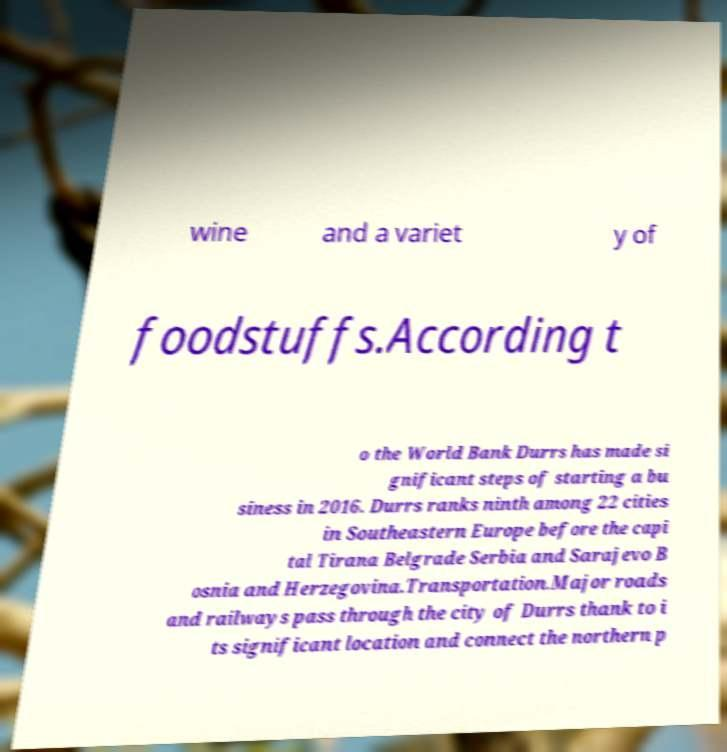Could you assist in decoding the text presented in this image and type it out clearly? wine and a variet y of foodstuffs.According t o the World Bank Durrs has made si gnificant steps of starting a bu siness in 2016. Durrs ranks ninth among 22 cities in Southeastern Europe before the capi tal Tirana Belgrade Serbia and Sarajevo B osnia and Herzegovina.Transportation.Major roads and railways pass through the city of Durrs thank to i ts significant location and connect the northern p 